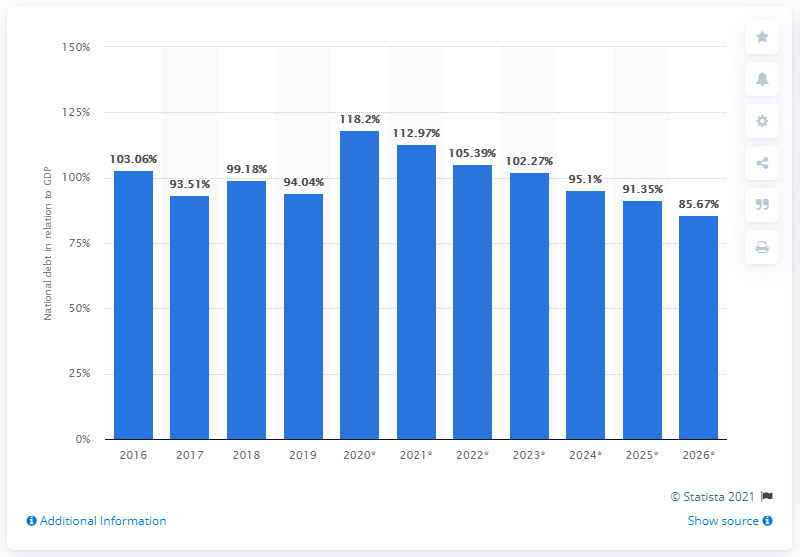Identify some key points in this picture. In 2019, the national debt of Cyprus accounted for approximately 94.04% of the country's Gross Domestic Product (GDP), a significant increase from the previous year. 